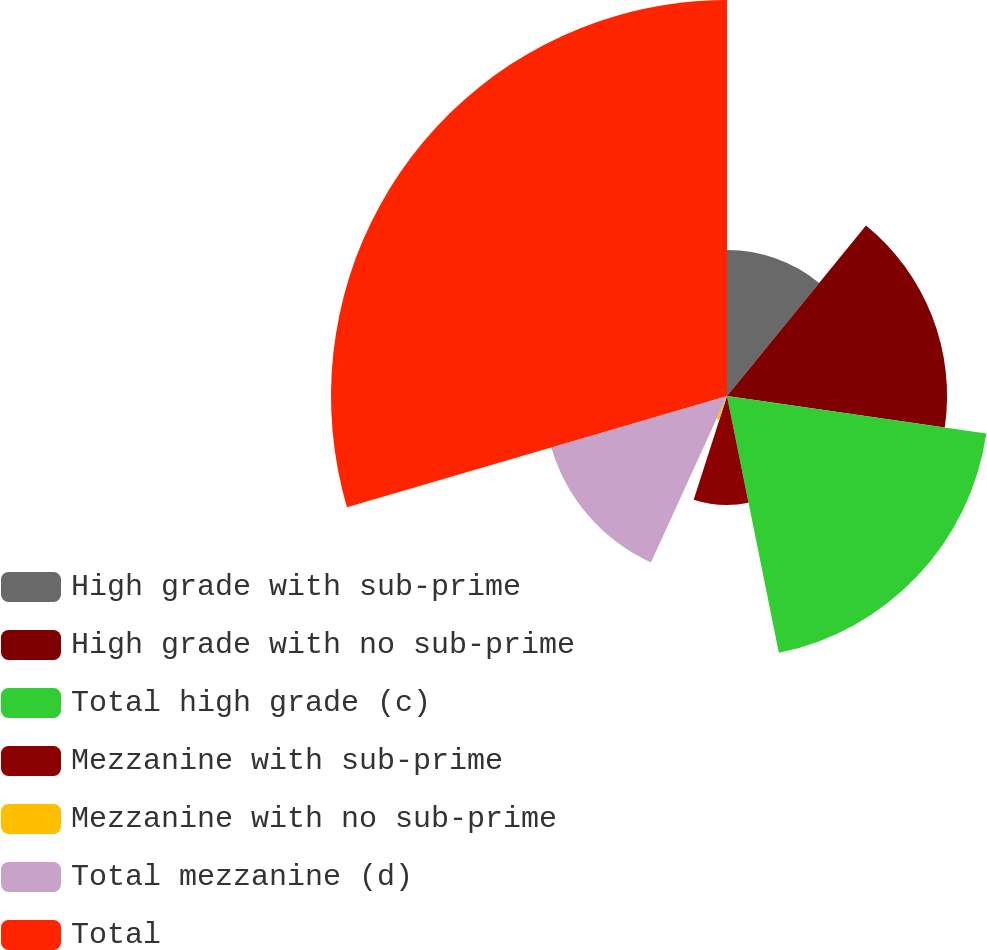<chart> <loc_0><loc_0><loc_500><loc_500><pie_chart><fcel>High grade with sub-prime<fcel>High grade with no sub-prime<fcel>Total high grade (c)<fcel>Mezzanine with sub-prime<fcel>Mezzanine with no sub-prime<fcel>Total mezzanine (d)<fcel>Total<nl><fcel>10.88%<fcel>16.41%<fcel>19.54%<fcel>8.12%<fcel>1.87%<fcel>13.65%<fcel>29.53%<nl></chart> 